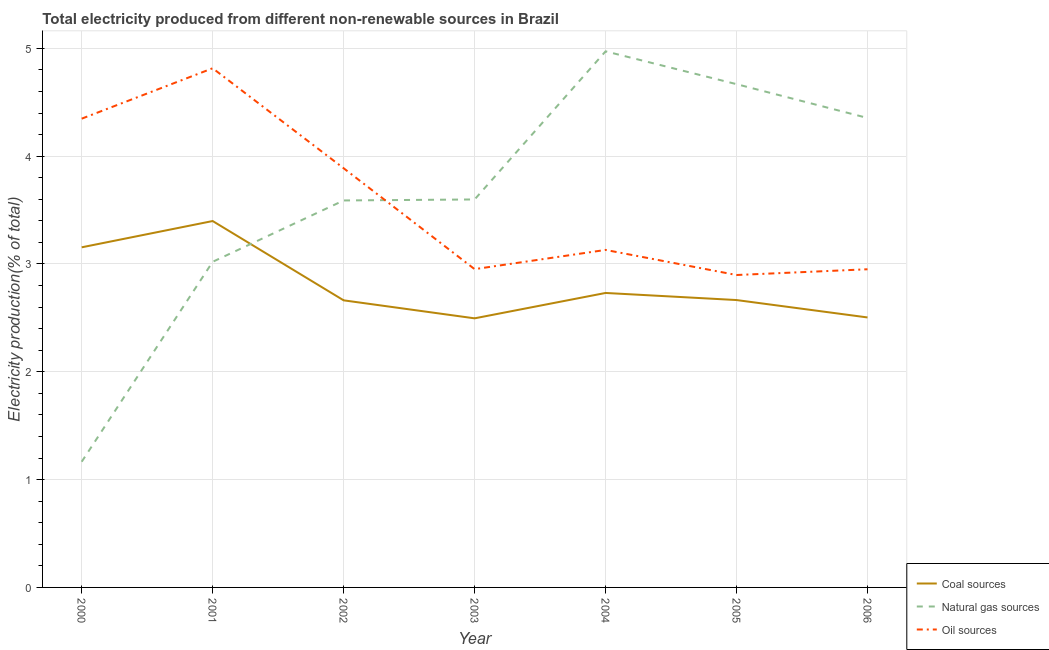How many different coloured lines are there?
Give a very brief answer. 3. Does the line corresponding to percentage of electricity produced by coal intersect with the line corresponding to percentage of electricity produced by oil sources?
Provide a succinct answer. No. What is the percentage of electricity produced by oil sources in 2003?
Provide a succinct answer. 2.95. Across all years, what is the maximum percentage of electricity produced by oil sources?
Your answer should be compact. 4.82. Across all years, what is the minimum percentage of electricity produced by coal?
Make the answer very short. 2.5. In which year was the percentage of electricity produced by oil sources maximum?
Provide a short and direct response. 2001. In which year was the percentage of electricity produced by natural gas minimum?
Your answer should be compact. 2000. What is the total percentage of electricity produced by coal in the graph?
Provide a succinct answer. 19.61. What is the difference between the percentage of electricity produced by oil sources in 2001 and that in 2003?
Your answer should be compact. 1.86. What is the difference between the percentage of electricity produced by natural gas in 2004 and the percentage of electricity produced by oil sources in 2002?
Make the answer very short. 1.08. What is the average percentage of electricity produced by natural gas per year?
Offer a very short reply. 3.62. In the year 2001, what is the difference between the percentage of electricity produced by oil sources and percentage of electricity produced by natural gas?
Keep it short and to the point. 1.8. What is the ratio of the percentage of electricity produced by natural gas in 2001 to that in 2003?
Your response must be concise. 0.84. Is the percentage of electricity produced by natural gas in 2002 less than that in 2003?
Provide a short and direct response. Yes. What is the difference between the highest and the second highest percentage of electricity produced by oil sources?
Offer a terse response. 0.47. What is the difference between the highest and the lowest percentage of electricity produced by natural gas?
Provide a short and direct response. 3.81. Is the sum of the percentage of electricity produced by natural gas in 2003 and 2005 greater than the maximum percentage of electricity produced by coal across all years?
Offer a terse response. Yes. Does the percentage of electricity produced by oil sources monotonically increase over the years?
Make the answer very short. No. How many lines are there?
Your response must be concise. 3. How many years are there in the graph?
Ensure brevity in your answer.  7. Are the values on the major ticks of Y-axis written in scientific E-notation?
Offer a very short reply. No. Does the graph contain any zero values?
Provide a succinct answer. No. Does the graph contain grids?
Your answer should be very brief. Yes. Where does the legend appear in the graph?
Ensure brevity in your answer.  Bottom right. How are the legend labels stacked?
Provide a short and direct response. Vertical. What is the title of the graph?
Your answer should be very brief. Total electricity produced from different non-renewable sources in Brazil. What is the label or title of the X-axis?
Keep it short and to the point. Year. What is the Electricity production(% of total) of Coal sources in 2000?
Your answer should be compact. 3.15. What is the Electricity production(% of total) in Natural gas sources in 2000?
Your answer should be compact. 1.17. What is the Electricity production(% of total) of Oil sources in 2000?
Give a very brief answer. 4.35. What is the Electricity production(% of total) in Coal sources in 2001?
Offer a terse response. 3.4. What is the Electricity production(% of total) of Natural gas sources in 2001?
Ensure brevity in your answer.  3.02. What is the Electricity production(% of total) of Oil sources in 2001?
Give a very brief answer. 4.82. What is the Electricity production(% of total) in Coal sources in 2002?
Your response must be concise. 2.66. What is the Electricity production(% of total) in Natural gas sources in 2002?
Your answer should be compact. 3.59. What is the Electricity production(% of total) in Oil sources in 2002?
Ensure brevity in your answer.  3.89. What is the Electricity production(% of total) in Coal sources in 2003?
Your answer should be compact. 2.5. What is the Electricity production(% of total) in Natural gas sources in 2003?
Keep it short and to the point. 3.6. What is the Electricity production(% of total) in Oil sources in 2003?
Keep it short and to the point. 2.95. What is the Electricity production(% of total) in Coal sources in 2004?
Offer a very short reply. 2.73. What is the Electricity production(% of total) of Natural gas sources in 2004?
Provide a succinct answer. 4.97. What is the Electricity production(% of total) in Oil sources in 2004?
Provide a succinct answer. 3.13. What is the Electricity production(% of total) of Coal sources in 2005?
Ensure brevity in your answer.  2.67. What is the Electricity production(% of total) of Natural gas sources in 2005?
Make the answer very short. 4.67. What is the Electricity production(% of total) in Oil sources in 2005?
Offer a very short reply. 2.9. What is the Electricity production(% of total) in Coal sources in 2006?
Provide a succinct answer. 2.5. What is the Electricity production(% of total) in Natural gas sources in 2006?
Provide a short and direct response. 4.35. What is the Electricity production(% of total) of Oil sources in 2006?
Keep it short and to the point. 2.95. Across all years, what is the maximum Electricity production(% of total) in Coal sources?
Your answer should be compact. 3.4. Across all years, what is the maximum Electricity production(% of total) of Natural gas sources?
Make the answer very short. 4.97. Across all years, what is the maximum Electricity production(% of total) in Oil sources?
Ensure brevity in your answer.  4.82. Across all years, what is the minimum Electricity production(% of total) of Coal sources?
Your answer should be very brief. 2.5. Across all years, what is the minimum Electricity production(% of total) in Natural gas sources?
Make the answer very short. 1.17. Across all years, what is the minimum Electricity production(% of total) of Oil sources?
Make the answer very short. 2.9. What is the total Electricity production(% of total) in Coal sources in the graph?
Provide a short and direct response. 19.61. What is the total Electricity production(% of total) of Natural gas sources in the graph?
Ensure brevity in your answer.  25.37. What is the total Electricity production(% of total) in Oil sources in the graph?
Keep it short and to the point. 24.98. What is the difference between the Electricity production(% of total) of Coal sources in 2000 and that in 2001?
Ensure brevity in your answer.  -0.24. What is the difference between the Electricity production(% of total) in Natural gas sources in 2000 and that in 2001?
Provide a short and direct response. -1.85. What is the difference between the Electricity production(% of total) in Oil sources in 2000 and that in 2001?
Make the answer very short. -0.47. What is the difference between the Electricity production(% of total) in Coal sources in 2000 and that in 2002?
Provide a short and direct response. 0.49. What is the difference between the Electricity production(% of total) in Natural gas sources in 2000 and that in 2002?
Provide a succinct answer. -2.42. What is the difference between the Electricity production(% of total) of Oil sources in 2000 and that in 2002?
Provide a short and direct response. 0.46. What is the difference between the Electricity production(% of total) in Coal sources in 2000 and that in 2003?
Provide a short and direct response. 0.66. What is the difference between the Electricity production(% of total) in Natural gas sources in 2000 and that in 2003?
Your response must be concise. -2.43. What is the difference between the Electricity production(% of total) of Oil sources in 2000 and that in 2003?
Keep it short and to the point. 1.4. What is the difference between the Electricity production(% of total) in Coal sources in 2000 and that in 2004?
Give a very brief answer. 0.42. What is the difference between the Electricity production(% of total) in Natural gas sources in 2000 and that in 2004?
Make the answer very short. -3.81. What is the difference between the Electricity production(% of total) of Oil sources in 2000 and that in 2004?
Give a very brief answer. 1.22. What is the difference between the Electricity production(% of total) in Coal sources in 2000 and that in 2005?
Make the answer very short. 0.49. What is the difference between the Electricity production(% of total) in Natural gas sources in 2000 and that in 2005?
Make the answer very short. -3.5. What is the difference between the Electricity production(% of total) in Oil sources in 2000 and that in 2005?
Your answer should be compact. 1.45. What is the difference between the Electricity production(% of total) in Coal sources in 2000 and that in 2006?
Your answer should be very brief. 0.65. What is the difference between the Electricity production(% of total) of Natural gas sources in 2000 and that in 2006?
Your answer should be very brief. -3.19. What is the difference between the Electricity production(% of total) of Oil sources in 2000 and that in 2006?
Provide a short and direct response. 1.4. What is the difference between the Electricity production(% of total) in Coal sources in 2001 and that in 2002?
Ensure brevity in your answer.  0.74. What is the difference between the Electricity production(% of total) in Natural gas sources in 2001 and that in 2002?
Ensure brevity in your answer.  -0.57. What is the difference between the Electricity production(% of total) in Oil sources in 2001 and that in 2002?
Your answer should be compact. 0.93. What is the difference between the Electricity production(% of total) in Coal sources in 2001 and that in 2003?
Provide a short and direct response. 0.9. What is the difference between the Electricity production(% of total) in Natural gas sources in 2001 and that in 2003?
Keep it short and to the point. -0.58. What is the difference between the Electricity production(% of total) in Oil sources in 2001 and that in 2003?
Give a very brief answer. 1.86. What is the difference between the Electricity production(% of total) in Coal sources in 2001 and that in 2004?
Give a very brief answer. 0.67. What is the difference between the Electricity production(% of total) in Natural gas sources in 2001 and that in 2004?
Make the answer very short. -1.95. What is the difference between the Electricity production(% of total) in Oil sources in 2001 and that in 2004?
Provide a short and direct response. 1.68. What is the difference between the Electricity production(% of total) of Coal sources in 2001 and that in 2005?
Your response must be concise. 0.73. What is the difference between the Electricity production(% of total) in Natural gas sources in 2001 and that in 2005?
Provide a succinct answer. -1.65. What is the difference between the Electricity production(% of total) of Oil sources in 2001 and that in 2005?
Offer a terse response. 1.92. What is the difference between the Electricity production(% of total) of Coal sources in 2001 and that in 2006?
Offer a terse response. 0.89. What is the difference between the Electricity production(% of total) of Natural gas sources in 2001 and that in 2006?
Provide a succinct answer. -1.33. What is the difference between the Electricity production(% of total) of Oil sources in 2001 and that in 2006?
Provide a short and direct response. 1.86. What is the difference between the Electricity production(% of total) in Coal sources in 2002 and that in 2003?
Ensure brevity in your answer.  0.17. What is the difference between the Electricity production(% of total) of Natural gas sources in 2002 and that in 2003?
Offer a very short reply. -0.01. What is the difference between the Electricity production(% of total) in Oil sources in 2002 and that in 2003?
Offer a terse response. 0.94. What is the difference between the Electricity production(% of total) of Coal sources in 2002 and that in 2004?
Provide a succinct answer. -0.07. What is the difference between the Electricity production(% of total) of Natural gas sources in 2002 and that in 2004?
Give a very brief answer. -1.38. What is the difference between the Electricity production(% of total) of Oil sources in 2002 and that in 2004?
Your answer should be very brief. 0.76. What is the difference between the Electricity production(% of total) of Coal sources in 2002 and that in 2005?
Your response must be concise. -0. What is the difference between the Electricity production(% of total) of Natural gas sources in 2002 and that in 2005?
Make the answer very short. -1.08. What is the difference between the Electricity production(% of total) of Oil sources in 2002 and that in 2005?
Keep it short and to the point. 0.99. What is the difference between the Electricity production(% of total) of Coal sources in 2002 and that in 2006?
Offer a terse response. 0.16. What is the difference between the Electricity production(% of total) of Natural gas sources in 2002 and that in 2006?
Give a very brief answer. -0.77. What is the difference between the Electricity production(% of total) in Oil sources in 2002 and that in 2006?
Ensure brevity in your answer.  0.94. What is the difference between the Electricity production(% of total) in Coal sources in 2003 and that in 2004?
Your answer should be compact. -0.24. What is the difference between the Electricity production(% of total) in Natural gas sources in 2003 and that in 2004?
Your answer should be very brief. -1.37. What is the difference between the Electricity production(% of total) in Oil sources in 2003 and that in 2004?
Your response must be concise. -0.18. What is the difference between the Electricity production(% of total) of Coal sources in 2003 and that in 2005?
Offer a very short reply. -0.17. What is the difference between the Electricity production(% of total) of Natural gas sources in 2003 and that in 2005?
Keep it short and to the point. -1.07. What is the difference between the Electricity production(% of total) of Oil sources in 2003 and that in 2005?
Your answer should be compact. 0.05. What is the difference between the Electricity production(% of total) in Coal sources in 2003 and that in 2006?
Keep it short and to the point. -0.01. What is the difference between the Electricity production(% of total) of Natural gas sources in 2003 and that in 2006?
Your response must be concise. -0.76. What is the difference between the Electricity production(% of total) in Oil sources in 2003 and that in 2006?
Provide a short and direct response. 0. What is the difference between the Electricity production(% of total) in Coal sources in 2004 and that in 2005?
Your answer should be very brief. 0.07. What is the difference between the Electricity production(% of total) in Natural gas sources in 2004 and that in 2005?
Your response must be concise. 0.3. What is the difference between the Electricity production(% of total) in Oil sources in 2004 and that in 2005?
Give a very brief answer. 0.23. What is the difference between the Electricity production(% of total) of Coal sources in 2004 and that in 2006?
Your answer should be very brief. 0.23. What is the difference between the Electricity production(% of total) of Natural gas sources in 2004 and that in 2006?
Keep it short and to the point. 0.62. What is the difference between the Electricity production(% of total) in Oil sources in 2004 and that in 2006?
Give a very brief answer. 0.18. What is the difference between the Electricity production(% of total) of Coal sources in 2005 and that in 2006?
Offer a terse response. 0.16. What is the difference between the Electricity production(% of total) of Natural gas sources in 2005 and that in 2006?
Provide a succinct answer. 0.31. What is the difference between the Electricity production(% of total) in Oil sources in 2005 and that in 2006?
Provide a short and direct response. -0.05. What is the difference between the Electricity production(% of total) in Coal sources in 2000 and the Electricity production(% of total) in Natural gas sources in 2001?
Make the answer very short. 0.13. What is the difference between the Electricity production(% of total) in Coal sources in 2000 and the Electricity production(% of total) in Oil sources in 2001?
Your answer should be compact. -1.66. What is the difference between the Electricity production(% of total) in Natural gas sources in 2000 and the Electricity production(% of total) in Oil sources in 2001?
Your answer should be compact. -3.65. What is the difference between the Electricity production(% of total) of Coal sources in 2000 and the Electricity production(% of total) of Natural gas sources in 2002?
Make the answer very short. -0.43. What is the difference between the Electricity production(% of total) of Coal sources in 2000 and the Electricity production(% of total) of Oil sources in 2002?
Give a very brief answer. -0.73. What is the difference between the Electricity production(% of total) of Natural gas sources in 2000 and the Electricity production(% of total) of Oil sources in 2002?
Your answer should be compact. -2.72. What is the difference between the Electricity production(% of total) of Coal sources in 2000 and the Electricity production(% of total) of Natural gas sources in 2003?
Your answer should be compact. -0.44. What is the difference between the Electricity production(% of total) in Coal sources in 2000 and the Electricity production(% of total) in Oil sources in 2003?
Give a very brief answer. 0.2. What is the difference between the Electricity production(% of total) in Natural gas sources in 2000 and the Electricity production(% of total) in Oil sources in 2003?
Provide a short and direct response. -1.79. What is the difference between the Electricity production(% of total) in Coal sources in 2000 and the Electricity production(% of total) in Natural gas sources in 2004?
Your answer should be compact. -1.82. What is the difference between the Electricity production(% of total) in Coal sources in 2000 and the Electricity production(% of total) in Oil sources in 2004?
Offer a very short reply. 0.02. What is the difference between the Electricity production(% of total) in Natural gas sources in 2000 and the Electricity production(% of total) in Oil sources in 2004?
Provide a short and direct response. -1.96. What is the difference between the Electricity production(% of total) in Coal sources in 2000 and the Electricity production(% of total) in Natural gas sources in 2005?
Make the answer very short. -1.51. What is the difference between the Electricity production(% of total) of Coal sources in 2000 and the Electricity production(% of total) of Oil sources in 2005?
Your answer should be very brief. 0.26. What is the difference between the Electricity production(% of total) in Natural gas sources in 2000 and the Electricity production(% of total) in Oil sources in 2005?
Provide a short and direct response. -1.73. What is the difference between the Electricity production(% of total) in Coal sources in 2000 and the Electricity production(% of total) in Natural gas sources in 2006?
Give a very brief answer. -1.2. What is the difference between the Electricity production(% of total) in Coal sources in 2000 and the Electricity production(% of total) in Oil sources in 2006?
Offer a very short reply. 0.2. What is the difference between the Electricity production(% of total) of Natural gas sources in 2000 and the Electricity production(% of total) of Oil sources in 2006?
Ensure brevity in your answer.  -1.78. What is the difference between the Electricity production(% of total) of Coal sources in 2001 and the Electricity production(% of total) of Natural gas sources in 2002?
Your answer should be compact. -0.19. What is the difference between the Electricity production(% of total) in Coal sources in 2001 and the Electricity production(% of total) in Oil sources in 2002?
Offer a terse response. -0.49. What is the difference between the Electricity production(% of total) in Natural gas sources in 2001 and the Electricity production(% of total) in Oil sources in 2002?
Your answer should be very brief. -0.87. What is the difference between the Electricity production(% of total) in Coal sources in 2001 and the Electricity production(% of total) in Natural gas sources in 2003?
Your answer should be very brief. -0.2. What is the difference between the Electricity production(% of total) of Coal sources in 2001 and the Electricity production(% of total) of Oil sources in 2003?
Give a very brief answer. 0.45. What is the difference between the Electricity production(% of total) of Natural gas sources in 2001 and the Electricity production(% of total) of Oil sources in 2003?
Provide a short and direct response. 0.07. What is the difference between the Electricity production(% of total) in Coal sources in 2001 and the Electricity production(% of total) in Natural gas sources in 2004?
Your answer should be very brief. -1.57. What is the difference between the Electricity production(% of total) in Coal sources in 2001 and the Electricity production(% of total) in Oil sources in 2004?
Provide a short and direct response. 0.27. What is the difference between the Electricity production(% of total) in Natural gas sources in 2001 and the Electricity production(% of total) in Oil sources in 2004?
Give a very brief answer. -0.11. What is the difference between the Electricity production(% of total) of Coal sources in 2001 and the Electricity production(% of total) of Natural gas sources in 2005?
Provide a succinct answer. -1.27. What is the difference between the Electricity production(% of total) in Coal sources in 2001 and the Electricity production(% of total) in Oil sources in 2005?
Offer a very short reply. 0.5. What is the difference between the Electricity production(% of total) in Natural gas sources in 2001 and the Electricity production(% of total) in Oil sources in 2005?
Your answer should be compact. 0.12. What is the difference between the Electricity production(% of total) of Coal sources in 2001 and the Electricity production(% of total) of Natural gas sources in 2006?
Your response must be concise. -0.96. What is the difference between the Electricity production(% of total) of Coal sources in 2001 and the Electricity production(% of total) of Oil sources in 2006?
Provide a succinct answer. 0.45. What is the difference between the Electricity production(% of total) of Natural gas sources in 2001 and the Electricity production(% of total) of Oil sources in 2006?
Provide a succinct answer. 0.07. What is the difference between the Electricity production(% of total) of Coal sources in 2002 and the Electricity production(% of total) of Natural gas sources in 2003?
Offer a terse response. -0.94. What is the difference between the Electricity production(% of total) of Coal sources in 2002 and the Electricity production(% of total) of Oil sources in 2003?
Provide a short and direct response. -0.29. What is the difference between the Electricity production(% of total) of Natural gas sources in 2002 and the Electricity production(% of total) of Oil sources in 2003?
Your answer should be compact. 0.64. What is the difference between the Electricity production(% of total) in Coal sources in 2002 and the Electricity production(% of total) in Natural gas sources in 2004?
Offer a very short reply. -2.31. What is the difference between the Electricity production(% of total) in Coal sources in 2002 and the Electricity production(% of total) in Oil sources in 2004?
Offer a terse response. -0.47. What is the difference between the Electricity production(% of total) of Natural gas sources in 2002 and the Electricity production(% of total) of Oil sources in 2004?
Keep it short and to the point. 0.46. What is the difference between the Electricity production(% of total) in Coal sources in 2002 and the Electricity production(% of total) in Natural gas sources in 2005?
Make the answer very short. -2. What is the difference between the Electricity production(% of total) of Coal sources in 2002 and the Electricity production(% of total) of Oil sources in 2005?
Give a very brief answer. -0.23. What is the difference between the Electricity production(% of total) in Natural gas sources in 2002 and the Electricity production(% of total) in Oil sources in 2005?
Your answer should be very brief. 0.69. What is the difference between the Electricity production(% of total) of Coal sources in 2002 and the Electricity production(% of total) of Natural gas sources in 2006?
Your response must be concise. -1.69. What is the difference between the Electricity production(% of total) in Coal sources in 2002 and the Electricity production(% of total) in Oil sources in 2006?
Your response must be concise. -0.29. What is the difference between the Electricity production(% of total) in Natural gas sources in 2002 and the Electricity production(% of total) in Oil sources in 2006?
Make the answer very short. 0.64. What is the difference between the Electricity production(% of total) of Coal sources in 2003 and the Electricity production(% of total) of Natural gas sources in 2004?
Your answer should be compact. -2.48. What is the difference between the Electricity production(% of total) in Coal sources in 2003 and the Electricity production(% of total) in Oil sources in 2004?
Make the answer very short. -0.63. What is the difference between the Electricity production(% of total) of Natural gas sources in 2003 and the Electricity production(% of total) of Oil sources in 2004?
Your answer should be compact. 0.47. What is the difference between the Electricity production(% of total) in Coal sources in 2003 and the Electricity production(% of total) in Natural gas sources in 2005?
Ensure brevity in your answer.  -2.17. What is the difference between the Electricity production(% of total) in Coal sources in 2003 and the Electricity production(% of total) in Oil sources in 2005?
Give a very brief answer. -0.4. What is the difference between the Electricity production(% of total) in Natural gas sources in 2003 and the Electricity production(% of total) in Oil sources in 2005?
Make the answer very short. 0.7. What is the difference between the Electricity production(% of total) in Coal sources in 2003 and the Electricity production(% of total) in Natural gas sources in 2006?
Your answer should be very brief. -1.86. What is the difference between the Electricity production(% of total) of Coal sources in 2003 and the Electricity production(% of total) of Oil sources in 2006?
Keep it short and to the point. -0.46. What is the difference between the Electricity production(% of total) of Natural gas sources in 2003 and the Electricity production(% of total) of Oil sources in 2006?
Your answer should be very brief. 0.65. What is the difference between the Electricity production(% of total) of Coal sources in 2004 and the Electricity production(% of total) of Natural gas sources in 2005?
Your answer should be very brief. -1.94. What is the difference between the Electricity production(% of total) of Coal sources in 2004 and the Electricity production(% of total) of Oil sources in 2005?
Your answer should be compact. -0.17. What is the difference between the Electricity production(% of total) of Natural gas sources in 2004 and the Electricity production(% of total) of Oil sources in 2005?
Make the answer very short. 2.07. What is the difference between the Electricity production(% of total) of Coal sources in 2004 and the Electricity production(% of total) of Natural gas sources in 2006?
Give a very brief answer. -1.62. What is the difference between the Electricity production(% of total) of Coal sources in 2004 and the Electricity production(% of total) of Oil sources in 2006?
Provide a succinct answer. -0.22. What is the difference between the Electricity production(% of total) of Natural gas sources in 2004 and the Electricity production(% of total) of Oil sources in 2006?
Ensure brevity in your answer.  2.02. What is the difference between the Electricity production(% of total) in Coal sources in 2005 and the Electricity production(% of total) in Natural gas sources in 2006?
Offer a terse response. -1.69. What is the difference between the Electricity production(% of total) in Coal sources in 2005 and the Electricity production(% of total) in Oil sources in 2006?
Keep it short and to the point. -0.29. What is the difference between the Electricity production(% of total) of Natural gas sources in 2005 and the Electricity production(% of total) of Oil sources in 2006?
Offer a terse response. 1.72. What is the average Electricity production(% of total) of Coal sources per year?
Your answer should be very brief. 2.8. What is the average Electricity production(% of total) in Natural gas sources per year?
Your answer should be very brief. 3.62. What is the average Electricity production(% of total) in Oil sources per year?
Keep it short and to the point. 3.57. In the year 2000, what is the difference between the Electricity production(% of total) in Coal sources and Electricity production(% of total) in Natural gas sources?
Ensure brevity in your answer.  1.99. In the year 2000, what is the difference between the Electricity production(% of total) in Coal sources and Electricity production(% of total) in Oil sources?
Provide a short and direct response. -1.19. In the year 2000, what is the difference between the Electricity production(% of total) of Natural gas sources and Electricity production(% of total) of Oil sources?
Your answer should be very brief. -3.18. In the year 2001, what is the difference between the Electricity production(% of total) in Coal sources and Electricity production(% of total) in Natural gas sources?
Offer a very short reply. 0.38. In the year 2001, what is the difference between the Electricity production(% of total) in Coal sources and Electricity production(% of total) in Oil sources?
Provide a short and direct response. -1.42. In the year 2001, what is the difference between the Electricity production(% of total) in Natural gas sources and Electricity production(% of total) in Oil sources?
Provide a succinct answer. -1.8. In the year 2002, what is the difference between the Electricity production(% of total) in Coal sources and Electricity production(% of total) in Natural gas sources?
Offer a terse response. -0.93. In the year 2002, what is the difference between the Electricity production(% of total) of Coal sources and Electricity production(% of total) of Oil sources?
Your answer should be very brief. -1.23. In the year 2002, what is the difference between the Electricity production(% of total) of Natural gas sources and Electricity production(% of total) of Oil sources?
Ensure brevity in your answer.  -0.3. In the year 2003, what is the difference between the Electricity production(% of total) in Coal sources and Electricity production(% of total) in Natural gas sources?
Offer a very short reply. -1.1. In the year 2003, what is the difference between the Electricity production(% of total) of Coal sources and Electricity production(% of total) of Oil sources?
Your answer should be very brief. -0.46. In the year 2003, what is the difference between the Electricity production(% of total) of Natural gas sources and Electricity production(% of total) of Oil sources?
Offer a terse response. 0.65. In the year 2004, what is the difference between the Electricity production(% of total) in Coal sources and Electricity production(% of total) in Natural gas sources?
Offer a very short reply. -2.24. In the year 2004, what is the difference between the Electricity production(% of total) in Coal sources and Electricity production(% of total) in Oil sources?
Offer a very short reply. -0.4. In the year 2004, what is the difference between the Electricity production(% of total) in Natural gas sources and Electricity production(% of total) in Oil sources?
Keep it short and to the point. 1.84. In the year 2005, what is the difference between the Electricity production(% of total) of Coal sources and Electricity production(% of total) of Natural gas sources?
Offer a terse response. -2. In the year 2005, what is the difference between the Electricity production(% of total) in Coal sources and Electricity production(% of total) in Oil sources?
Your answer should be very brief. -0.23. In the year 2005, what is the difference between the Electricity production(% of total) of Natural gas sources and Electricity production(% of total) of Oil sources?
Give a very brief answer. 1.77. In the year 2006, what is the difference between the Electricity production(% of total) in Coal sources and Electricity production(% of total) in Natural gas sources?
Keep it short and to the point. -1.85. In the year 2006, what is the difference between the Electricity production(% of total) of Coal sources and Electricity production(% of total) of Oil sources?
Provide a short and direct response. -0.45. In the year 2006, what is the difference between the Electricity production(% of total) in Natural gas sources and Electricity production(% of total) in Oil sources?
Provide a succinct answer. 1.4. What is the ratio of the Electricity production(% of total) of Coal sources in 2000 to that in 2001?
Provide a succinct answer. 0.93. What is the ratio of the Electricity production(% of total) of Natural gas sources in 2000 to that in 2001?
Keep it short and to the point. 0.39. What is the ratio of the Electricity production(% of total) in Oil sources in 2000 to that in 2001?
Ensure brevity in your answer.  0.9. What is the ratio of the Electricity production(% of total) of Coal sources in 2000 to that in 2002?
Your response must be concise. 1.18. What is the ratio of the Electricity production(% of total) of Natural gas sources in 2000 to that in 2002?
Offer a terse response. 0.32. What is the ratio of the Electricity production(% of total) in Oil sources in 2000 to that in 2002?
Provide a short and direct response. 1.12. What is the ratio of the Electricity production(% of total) of Coal sources in 2000 to that in 2003?
Make the answer very short. 1.26. What is the ratio of the Electricity production(% of total) of Natural gas sources in 2000 to that in 2003?
Offer a terse response. 0.32. What is the ratio of the Electricity production(% of total) in Oil sources in 2000 to that in 2003?
Offer a terse response. 1.47. What is the ratio of the Electricity production(% of total) in Coal sources in 2000 to that in 2004?
Ensure brevity in your answer.  1.16. What is the ratio of the Electricity production(% of total) in Natural gas sources in 2000 to that in 2004?
Offer a very short reply. 0.23. What is the ratio of the Electricity production(% of total) in Oil sources in 2000 to that in 2004?
Provide a succinct answer. 1.39. What is the ratio of the Electricity production(% of total) of Coal sources in 2000 to that in 2005?
Provide a short and direct response. 1.18. What is the ratio of the Electricity production(% of total) of Natural gas sources in 2000 to that in 2005?
Ensure brevity in your answer.  0.25. What is the ratio of the Electricity production(% of total) of Oil sources in 2000 to that in 2005?
Offer a very short reply. 1.5. What is the ratio of the Electricity production(% of total) in Coal sources in 2000 to that in 2006?
Offer a terse response. 1.26. What is the ratio of the Electricity production(% of total) in Natural gas sources in 2000 to that in 2006?
Make the answer very short. 0.27. What is the ratio of the Electricity production(% of total) of Oil sources in 2000 to that in 2006?
Offer a terse response. 1.47. What is the ratio of the Electricity production(% of total) of Coal sources in 2001 to that in 2002?
Keep it short and to the point. 1.28. What is the ratio of the Electricity production(% of total) in Natural gas sources in 2001 to that in 2002?
Make the answer very short. 0.84. What is the ratio of the Electricity production(% of total) of Oil sources in 2001 to that in 2002?
Your answer should be very brief. 1.24. What is the ratio of the Electricity production(% of total) of Coal sources in 2001 to that in 2003?
Your answer should be compact. 1.36. What is the ratio of the Electricity production(% of total) in Natural gas sources in 2001 to that in 2003?
Keep it short and to the point. 0.84. What is the ratio of the Electricity production(% of total) in Oil sources in 2001 to that in 2003?
Provide a succinct answer. 1.63. What is the ratio of the Electricity production(% of total) in Coal sources in 2001 to that in 2004?
Provide a short and direct response. 1.24. What is the ratio of the Electricity production(% of total) of Natural gas sources in 2001 to that in 2004?
Your answer should be compact. 0.61. What is the ratio of the Electricity production(% of total) of Oil sources in 2001 to that in 2004?
Make the answer very short. 1.54. What is the ratio of the Electricity production(% of total) in Coal sources in 2001 to that in 2005?
Your answer should be compact. 1.27. What is the ratio of the Electricity production(% of total) in Natural gas sources in 2001 to that in 2005?
Make the answer very short. 0.65. What is the ratio of the Electricity production(% of total) in Oil sources in 2001 to that in 2005?
Provide a succinct answer. 1.66. What is the ratio of the Electricity production(% of total) of Coal sources in 2001 to that in 2006?
Offer a terse response. 1.36. What is the ratio of the Electricity production(% of total) in Natural gas sources in 2001 to that in 2006?
Ensure brevity in your answer.  0.69. What is the ratio of the Electricity production(% of total) of Oil sources in 2001 to that in 2006?
Ensure brevity in your answer.  1.63. What is the ratio of the Electricity production(% of total) of Coal sources in 2002 to that in 2003?
Make the answer very short. 1.07. What is the ratio of the Electricity production(% of total) in Oil sources in 2002 to that in 2003?
Give a very brief answer. 1.32. What is the ratio of the Electricity production(% of total) in Coal sources in 2002 to that in 2004?
Your answer should be very brief. 0.97. What is the ratio of the Electricity production(% of total) of Natural gas sources in 2002 to that in 2004?
Keep it short and to the point. 0.72. What is the ratio of the Electricity production(% of total) in Oil sources in 2002 to that in 2004?
Ensure brevity in your answer.  1.24. What is the ratio of the Electricity production(% of total) of Natural gas sources in 2002 to that in 2005?
Provide a succinct answer. 0.77. What is the ratio of the Electricity production(% of total) in Oil sources in 2002 to that in 2005?
Your answer should be very brief. 1.34. What is the ratio of the Electricity production(% of total) of Coal sources in 2002 to that in 2006?
Your response must be concise. 1.06. What is the ratio of the Electricity production(% of total) of Natural gas sources in 2002 to that in 2006?
Keep it short and to the point. 0.82. What is the ratio of the Electricity production(% of total) in Oil sources in 2002 to that in 2006?
Offer a terse response. 1.32. What is the ratio of the Electricity production(% of total) of Coal sources in 2003 to that in 2004?
Offer a very short reply. 0.91. What is the ratio of the Electricity production(% of total) of Natural gas sources in 2003 to that in 2004?
Keep it short and to the point. 0.72. What is the ratio of the Electricity production(% of total) in Oil sources in 2003 to that in 2004?
Provide a short and direct response. 0.94. What is the ratio of the Electricity production(% of total) of Coal sources in 2003 to that in 2005?
Offer a terse response. 0.94. What is the ratio of the Electricity production(% of total) in Natural gas sources in 2003 to that in 2005?
Offer a very short reply. 0.77. What is the ratio of the Electricity production(% of total) in Oil sources in 2003 to that in 2005?
Keep it short and to the point. 1.02. What is the ratio of the Electricity production(% of total) of Natural gas sources in 2003 to that in 2006?
Make the answer very short. 0.83. What is the ratio of the Electricity production(% of total) in Coal sources in 2004 to that in 2005?
Your answer should be very brief. 1.02. What is the ratio of the Electricity production(% of total) of Natural gas sources in 2004 to that in 2005?
Make the answer very short. 1.07. What is the ratio of the Electricity production(% of total) in Oil sources in 2004 to that in 2005?
Ensure brevity in your answer.  1.08. What is the ratio of the Electricity production(% of total) in Coal sources in 2004 to that in 2006?
Ensure brevity in your answer.  1.09. What is the ratio of the Electricity production(% of total) of Natural gas sources in 2004 to that in 2006?
Your response must be concise. 1.14. What is the ratio of the Electricity production(% of total) of Oil sources in 2004 to that in 2006?
Keep it short and to the point. 1.06. What is the ratio of the Electricity production(% of total) of Coal sources in 2005 to that in 2006?
Keep it short and to the point. 1.06. What is the ratio of the Electricity production(% of total) in Natural gas sources in 2005 to that in 2006?
Provide a succinct answer. 1.07. What is the ratio of the Electricity production(% of total) of Oil sources in 2005 to that in 2006?
Offer a terse response. 0.98. What is the difference between the highest and the second highest Electricity production(% of total) in Coal sources?
Offer a very short reply. 0.24. What is the difference between the highest and the second highest Electricity production(% of total) in Natural gas sources?
Offer a terse response. 0.3. What is the difference between the highest and the second highest Electricity production(% of total) in Oil sources?
Your answer should be very brief. 0.47. What is the difference between the highest and the lowest Electricity production(% of total) of Coal sources?
Keep it short and to the point. 0.9. What is the difference between the highest and the lowest Electricity production(% of total) in Natural gas sources?
Your answer should be very brief. 3.81. What is the difference between the highest and the lowest Electricity production(% of total) in Oil sources?
Offer a terse response. 1.92. 